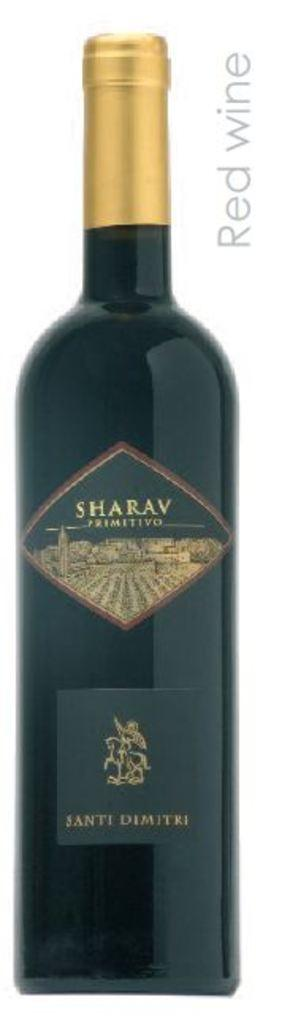What is the main object in the center of the image? There is a wine bottle in the center of the image. Is there any text present in the image? Yes, there is text in the top right corner of the image. What type of alarm is going off in the image? There is no alarm present in the image; it only features a wine bottle and text. Are there any police officers visible in the image? There are no police officers present in the image. 